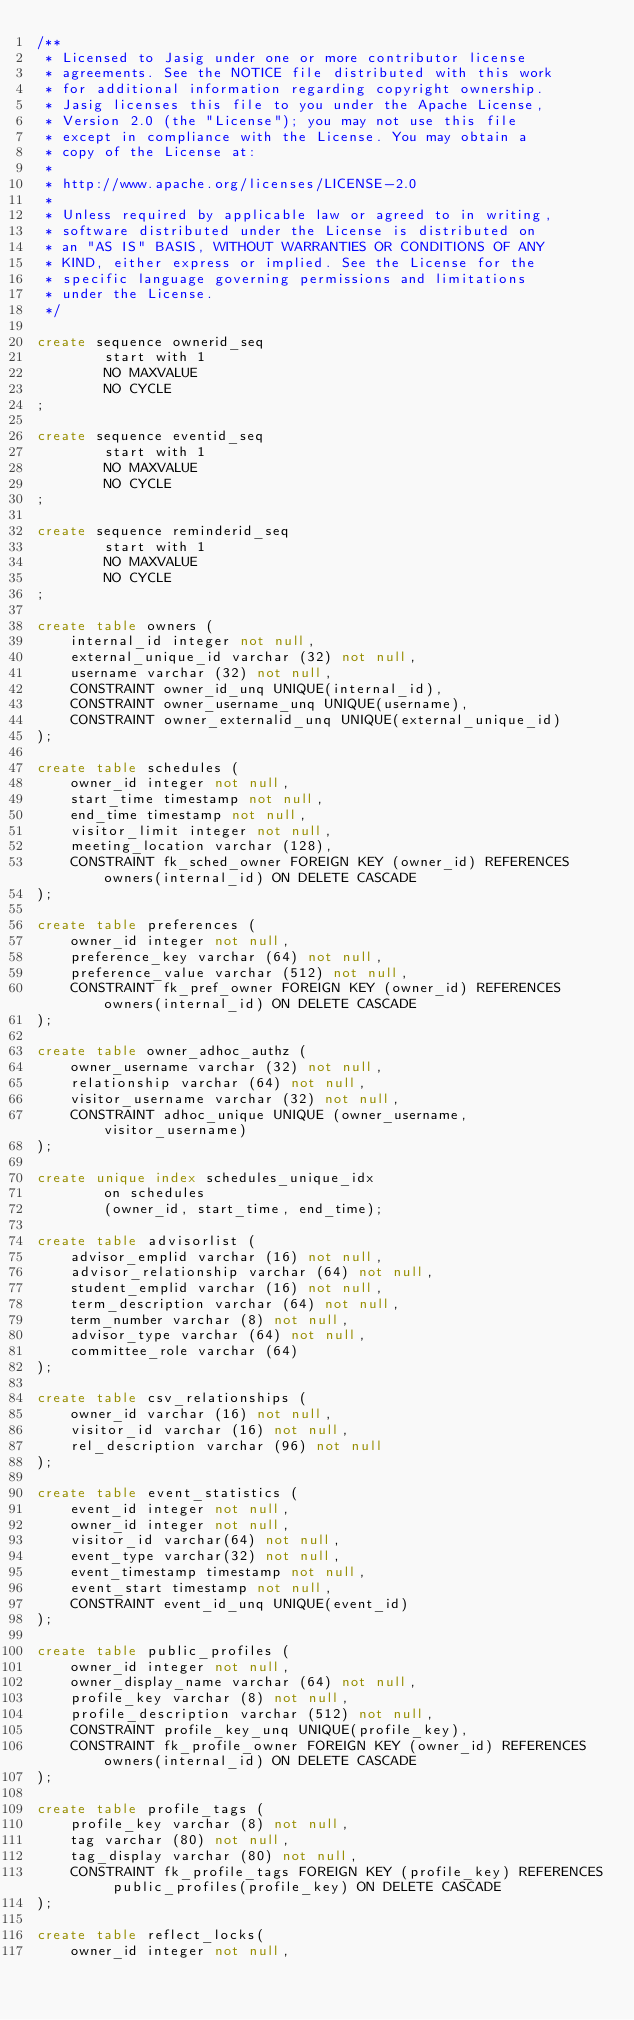Convert code to text. <code><loc_0><loc_0><loc_500><loc_500><_SQL_>/**
 * Licensed to Jasig under one or more contributor license
 * agreements. See the NOTICE file distributed with this work
 * for additional information regarding copyright ownership.
 * Jasig licenses this file to you under the Apache License,
 * Version 2.0 (the "License"); you may not use this file
 * except in compliance with the License. You may obtain a
 * copy of the License at:
 *
 * http://www.apache.org/licenses/LICENSE-2.0
 *
 * Unless required by applicable law or agreed to in writing,
 * software distributed under the License is distributed on
 * an "AS IS" BASIS, WITHOUT WARRANTIES OR CONDITIONS OF ANY
 * KIND, either express or implied. See the License for the
 * specific language governing permissions and limitations
 * under the License.
 */

create sequence ownerid_seq
        start with 1
        NO MAXVALUE
        NO CYCLE
;

create sequence eventid_seq
        start with 1
        NO MAXVALUE
        NO CYCLE
;

create sequence reminderid_seq
        start with 1
        NO MAXVALUE
        NO CYCLE
;

create table owners (
	internal_id integer not null,
	external_unique_id varchar (32) not null,
	username varchar (32) not null,
	CONSTRAINT owner_id_unq UNIQUE(internal_id),
	CONSTRAINT owner_username_unq UNIQUE(username),
	CONSTRAINT owner_externalid_unq UNIQUE(external_unique_id)
);

create table schedules (
	owner_id integer not null,
	start_time timestamp not null,
	end_time timestamp not null,
	visitor_limit integer not null,
	meeting_location varchar (128),
	CONSTRAINT fk_sched_owner FOREIGN KEY (owner_id) REFERENCES owners(internal_id) ON DELETE CASCADE
);

create table preferences (
	owner_id integer not null,
	preference_key varchar (64) not null,
	preference_value varchar (512) not null,
	CONSTRAINT fk_pref_owner FOREIGN KEY (owner_id) REFERENCES owners(internal_id) ON DELETE CASCADE
);

create table owner_adhoc_authz (
	owner_username varchar (32) not null,
	relationship varchar (64) not null,
	visitor_username varchar (32) not null,
	CONSTRAINT adhoc_unique UNIQUE (owner_username, visitor_username)
);

create unique index schedules_unique_idx 
		on schedules
		(owner_id, start_time, end_time);
		
create table advisorlist (
	advisor_emplid varchar (16) not null,
	advisor_relationship varchar (64) not null,
	student_emplid varchar (16) not null,
	term_description varchar (64) not null,
	term_number varchar (8) not null,
	advisor_type varchar (64) not null,
	committee_role varchar (64)
);

create table csv_relationships (
	owner_id varchar (16) not null,
	visitor_id varchar (16) not null,
	rel_description varchar (96) not null
);

create table event_statistics (
	event_id integer not null,
	owner_id integer not null,
	visitor_id varchar(64) not null,
	event_type varchar(32) not null,
	event_timestamp timestamp not null,
	event_start timestamp not null,
	CONSTRAINT event_id_unq UNIQUE(event_id)
);

create table public_profiles (
	owner_id integer not null,
	owner_display_name varchar (64) not null,
 	profile_key varchar (8) not null,
	profile_description varchar (512) not null,
	CONSTRAINT profile_key_unq UNIQUE(profile_key),
	CONSTRAINT fk_profile_owner FOREIGN KEY (owner_id) REFERENCES owners(internal_id) ON DELETE CASCADE
);

create table profile_tags (
	profile_key varchar (8) not null,
	tag varchar (80) not null,
	tag_display varchar (80) not null,
	CONSTRAINT fk_profile_tags FOREIGN KEY (profile_key) REFERENCES public_profiles(profile_key) ON DELETE CASCADE
);

create table reflect_locks(
	owner_id integer not null,</code> 